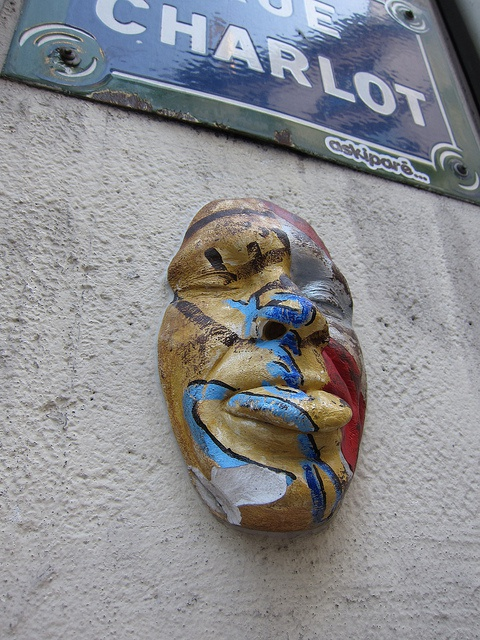Describe the objects in this image and their specific colors. I can see people in gray, olive, darkgray, and maroon tones in this image. 